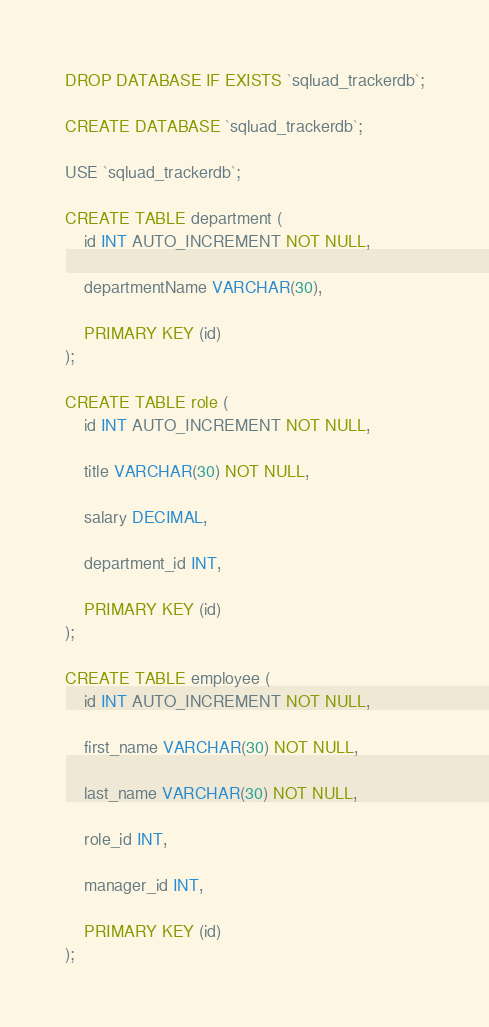<code> <loc_0><loc_0><loc_500><loc_500><_SQL_>DROP DATABASE IF EXISTS `sqluad_trackerdb`;

CREATE DATABASE `sqluad_trackerdb`;

USE `sqluad_trackerdb`;

CREATE TABLE department (
    id INT AUTO_INCREMENT NOT NULL,

    departmentName VARCHAR(30),

    PRIMARY KEY (id)
);

CREATE TABLE role (
    id INT AUTO_INCREMENT NOT NULL,

    title VARCHAR(30) NOT NULL,

    salary DECIMAL,

    department_id INT,

    PRIMARY KEY (id)
);

CREATE TABLE employee (
    id INT AUTO_INCREMENT NOT NULL,

    first_name VARCHAR(30) NOT NULL,

    last_name VARCHAR(30) NOT NULL,

    role_id INT,

    manager_id INT,

    PRIMARY KEY (id)
);</code> 